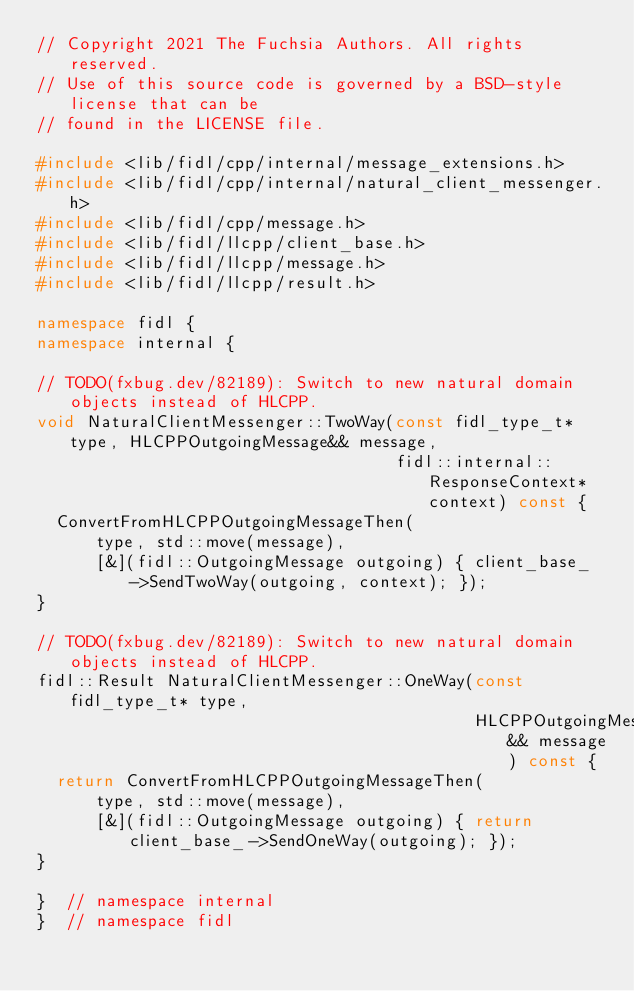Convert code to text. <code><loc_0><loc_0><loc_500><loc_500><_C++_>// Copyright 2021 The Fuchsia Authors. All rights reserved.
// Use of this source code is governed by a BSD-style license that can be
// found in the LICENSE file.

#include <lib/fidl/cpp/internal/message_extensions.h>
#include <lib/fidl/cpp/internal/natural_client_messenger.h>
#include <lib/fidl/cpp/message.h>
#include <lib/fidl/llcpp/client_base.h>
#include <lib/fidl/llcpp/message.h>
#include <lib/fidl/llcpp/result.h>

namespace fidl {
namespace internal {

// TODO(fxbug.dev/82189): Switch to new natural domain objects instead of HLCPP.
void NaturalClientMessenger::TwoWay(const fidl_type_t* type, HLCPPOutgoingMessage&& message,
                                    fidl::internal::ResponseContext* context) const {
  ConvertFromHLCPPOutgoingMessageThen(
      type, std::move(message),
      [&](fidl::OutgoingMessage outgoing) { client_base_->SendTwoWay(outgoing, context); });
}

// TODO(fxbug.dev/82189): Switch to new natural domain objects instead of HLCPP.
fidl::Result NaturalClientMessenger::OneWay(const fidl_type_t* type,
                                            HLCPPOutgoingMessage&& message) const {
  return ConvertFromHLCPPOutgoingMessageThen(
      type, std::move(message),
      [&](fidl::OutgoingMessage outgoing) { return client_base_->SendOneWay(outgoing); });
}

}  // namespace internal
}  // namespace fidl
</code> 